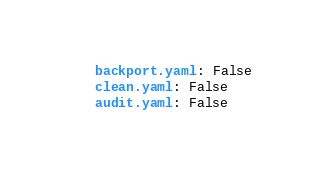Convert code to text. <code><loc_0><loc_0><loc_500><loc_500><_YAML_>    backport.yaml: False
    clean.yaml: False
    audit.yaml: False
</code> 